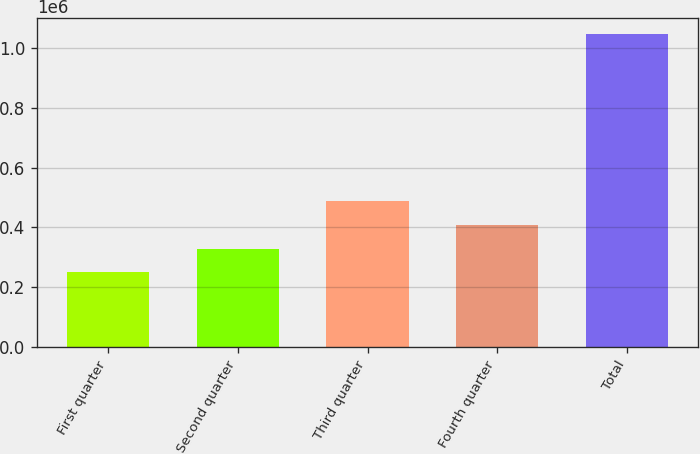Convert chart. <chart><loc_0><loc_0><loc_500><loc_500><bar_chart><fcel>First quarter<fcel>Second quarter<fcel>Third quarter<fcel>Fourth quarter<fcel>Total<nl><fcel>249515<fcel>329321<fcel>488933<fcel>409127<fcel>1.04757e+06<nl></chart> 